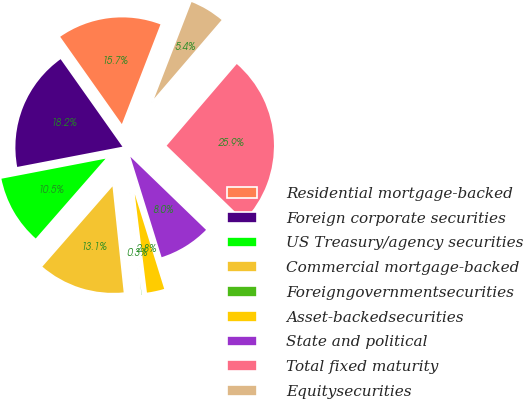Convert chart. <chart><loc_0><loc_0><loc_500><loc_500><pie_chart><fcel>Residential mortgage-backed<fcel>Foreign corporate securities<fcel>US Treasury/agency securities<fcel>Commercial mortgage-backed<fcel>Foreigngovernmentsecurities<fcel>Asset-backedsecurities<fcel>State and political<fcel>Total fixed maturity<fcel>Equitysecurities<nl><fcel>15.67%<fcel>18.24%<fcel>10.54%<fcel>13.11%<fcel>0.28%<fcel>2.84%<fcel>7.98%<fcel>25.94%<fcel>5.41%<nl></chart> 